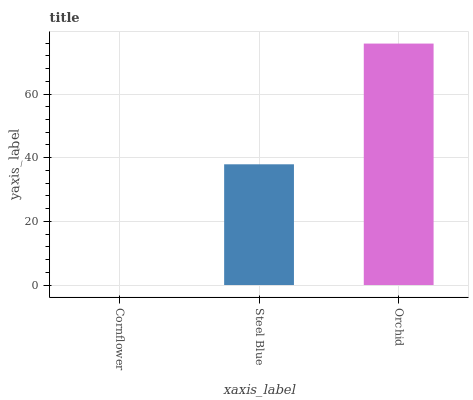Is Cornflower the minimum?
Answer yes or no. Yes. Is Orchid the maximum?
Answer yes or no. Yes. Is Steel Blue the minimum?
Answer yes or no. No. Is Steel Blue the maximum?
Answer yes or no. No. Is Steel Blue greater than Cornflower?
Answer yes or no. Yes. Is Cornflower less than Steel Blue?
Answer yes or no. Yes. Is Cornflower greater than Steel Blue?
Answer yes or no. No. Is Steel Blue less than Cornflower?
Answer yes or no. No. Is Steel Blue the high median?
Answer yes or no. Yes. Is Steel Blue the low median?
Answer yes or no. Yes. Is Cornflower the high median?
Answer yes or no. No. Is Cornflower the low median?
Answer yes or no. No. 